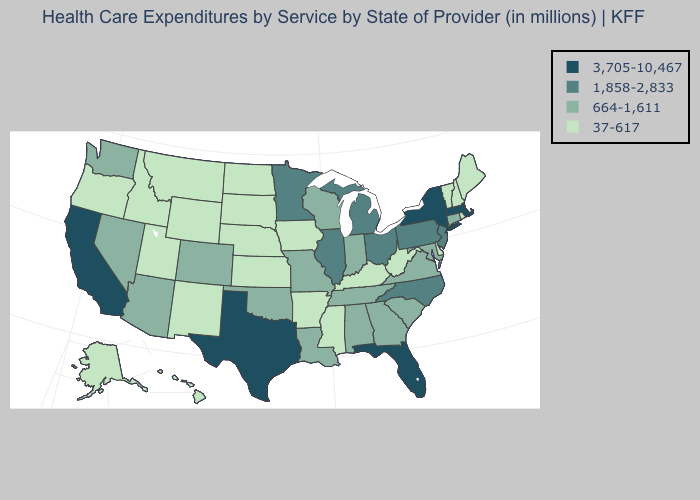Name the states that have a value in the range 37-617?
Answer briefly. Alaska, Arkansas, Delaware, Hawaii, Idaho, Iowa, Kansas, Kentucky, Maine, Mississippi, Montana, Nebraska, New Hampshire, New Mexico, North Dakota, Oregon, Rhode Island, South Dakota, Utah, Vermont, West Virginia, Wyoming. Which states have the lowest value in the USA?
Write a very short answer. Alaska, Arkansas, Delaware, Hawaii, Idaho, Iowa, Kansas, Kentucky, Maine, Mississippi, Montana, Nebraska, New Hampshire, New Mexico, North Dakota, Oregon, Rhode Island, South Dakota, Utah, Vermont, West Virginia, Wyoming. Name the states that have a value in the range 37-617?
Short answer required. Alaska, Arkansas, Delaware, Hawaii, Idaho, Iowa, Kansas, Kentucky, Maine, Mississippi, Montana, Nebraska, New Hampshire, New Mexico, North Dakota, Oregon, Rhode Island, South Dakota, Utah, Vermont, West Virginia, Wyoming. What is the highest value in the USA?
Quick response, please. 3,705-10,467. Does Maryland have a higher value than Kentucky?
Give a very brief answer. Yes. Name the states that have a value in the range 1,858-2,833?
Answer briefly. Illinois, Michigan, Minnesota, New Jersey, North Carolina, Ohio, Pennsylvania. What is the lowest value in states that border Delaware?
Answer briefly. 664-1,611. What is the value of Michigan?
Short answer required. 1,858-2,833. What is the value of Nevada?
Short answer required. 664-1,611. Among the states that border Ohio , does Indiana have the highest value?
Give a very brief answer. No. Does North Carolina have a lower value than California?
Answer briefly. Yes. Does Kansas have the highest value in the USA?
Write a very short answer. No. What is the value of Missouri?
Keep it brief. 664-1,611. Name the states that have a value in the range 37-617?
Short answer required. Alaska, Arkansas, Delaware, Hawaii, Idaho, Iowa, Kansas, Kentucky, Maine, Mississippi, Montana, Nebraska, New Hampshire, New Mexico, North Dakota, Oregon, Rhode Island, South Dakota, Utah, Vermont, West Virginia, Wyoming. Which states hav the highest value in the MidWest?
Concise answer only. Illinois, Michigan, Minnesota, Ohio. 